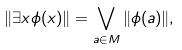<formula> <loc_0><loc_0><loc_500><loc_500>\| \exists x \phi ( x ) \| = \bigvee _ { a \in M } \| \phi ( a ) \| ,</formula> 